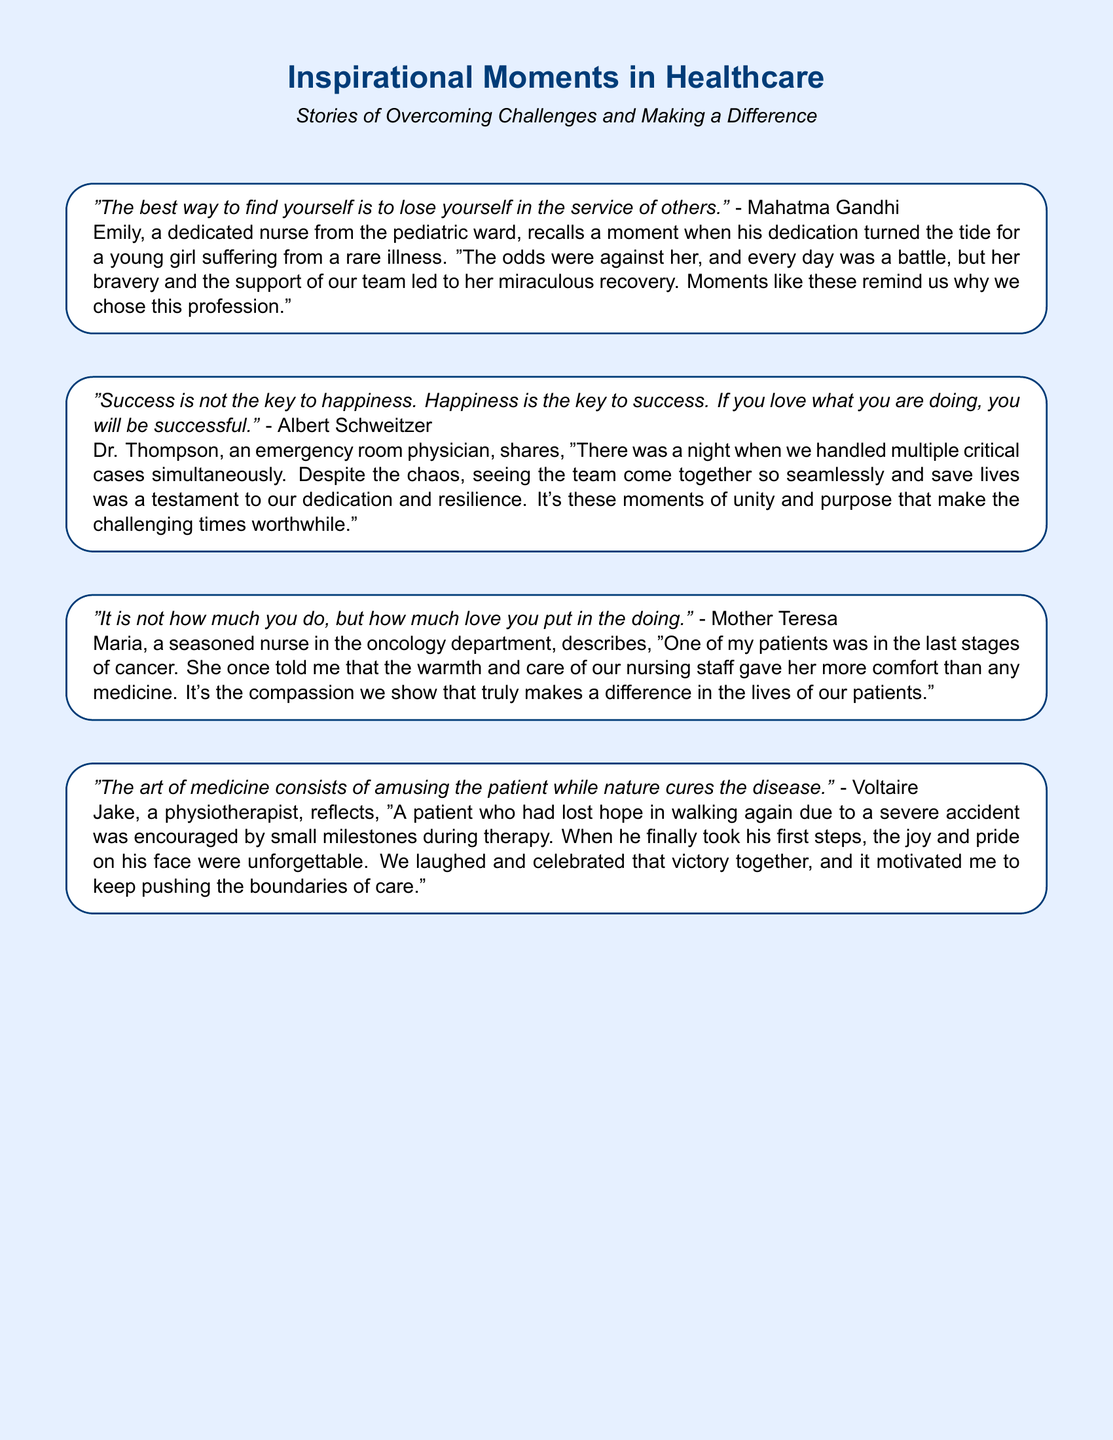What is the title of the document? The title is prominently featured at the top of the document, which is "Inspirational Moments in Healthcare."
Answer: Inspirational Moments in Healthcare Who is quoted in the first story? The first story cites Mahatma Gandhi, who is quoted about service to others.
Answer: Mahatma Gandhi What department does nurse Maria work in? The document states that Maria works in the oncology department.
Answer: Oncology department What did Dr. Thompson witness during his shift? The document describes Dr. Thompson witnessing a seamless team effort during a chaotic night in the emergency room.
Answer: Team effort Which healthcare professional is associated with the first steps of a patient? Jake, a physiotherapist, is the professional who encouraged a patient to take his first steps.
Answer: Jake What emotion did the patient express when he walked again? The patient expressed joy when he took his first steps after therapy.
Answer: Joy How many quotes are included in the document? There are four quotes presented throughout the document.
Answer: Four What theme is presented along with the inspirational quotes? The theme presented alongside the quotes involves overcoming challenges and making a difference in healthcare.
Answer: Overcoming challenges and making a difference 